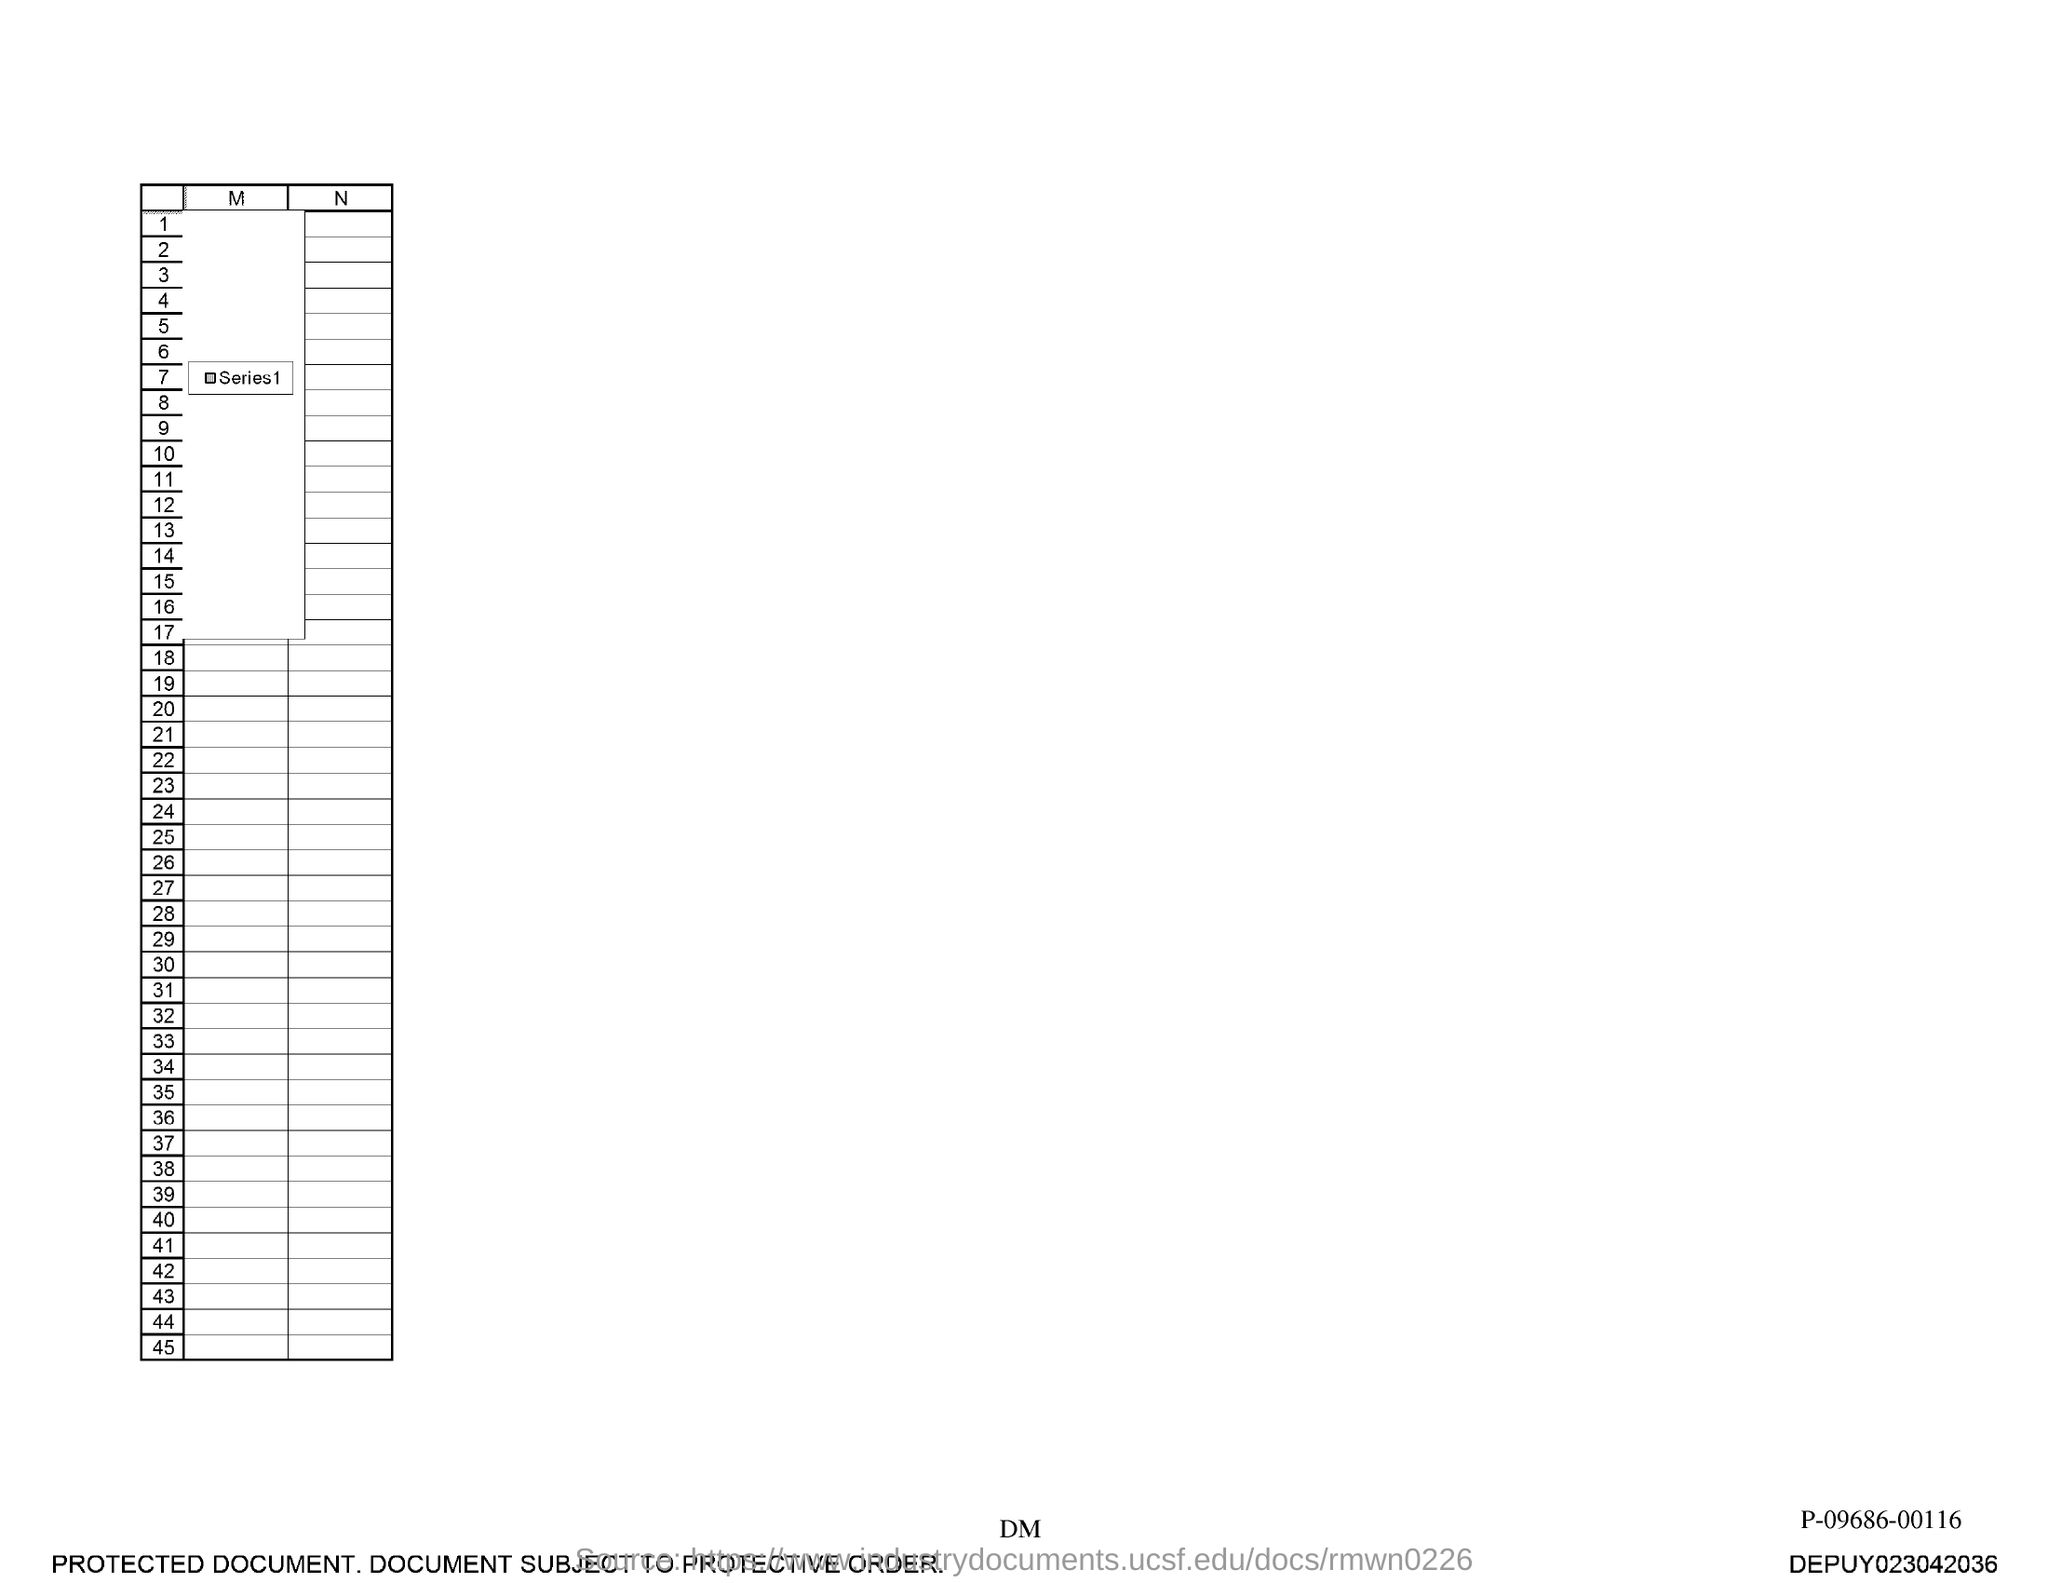What is the last number in the first column?
Your answer should be compact. 45. 